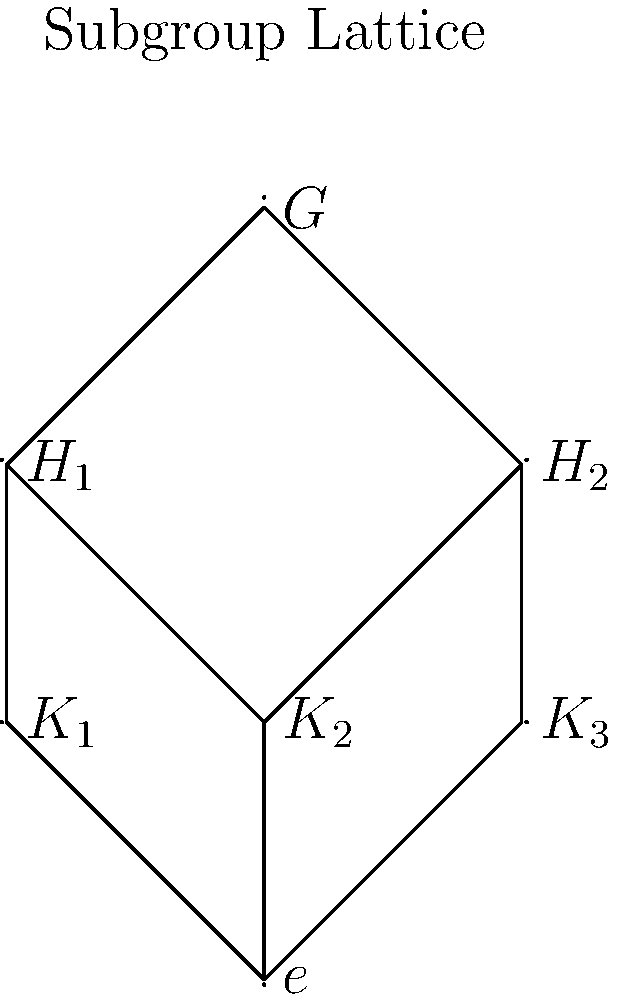Given the subgroup lattice of a finite group $G$ as shown in the diagram, how might this structure be utilized to design a hierarchical database schema for a complex system? Specifically, explain how the relationships between subgroups could be mapped to database tables and their relationships. To utilize the subgroup lattice structure in designing a hierarchical database schema, we can follow these steps:

1. Identify main entities: Each node in the lattice represents a potential entity or table in the database. In this case, we have $G$, $H_1$, $H_2$, $K_1$, $K_2$, $K_3$, and $e$.

2. Establish hierarchical relationships: The edges in the lattice represent hierarchical relationships between entities. For example, $H_1$ and $H_2$ are direct "children" of $G$.

3. Design primary and foreign keys:
   - Assign a unique identifier (primary key) to each entity.
   - Use foreign keys to represent the hierarchical relationships.

4. Create tables:
   - Create a table for each node (subgroup) in the lattice.
   - Include columns for the primary key and any relevant attributes.
   - Add foreign key columns to represent relationships with parent entities.

5. Implement constraints:
   - Use foreign key constraints to enforce the hierarchical structure.
   - Ensure that each entity can only have one direct parent (except for $G$, which is the root).

6. Handle multiple inheritance:
   - Note that $K_2$ has two parent nodes ($H_1$ and $H_2$). This represents a form of multiple inheritance.
   - Implement this using multiple foreign key relationships or a junction table.

7. Optimize for queries:
   - Consider adding redundant data or denormalization techniques to optimize for common queries that traverse the hierarchy.

8. Implement security and access control:
   - Use the hierarchical structure to implement role-based access control, where access to lower-level entities implies access to higher-level entities.

By mapping the subgroup lattice to a database schema in this way, we create a structure that reflects the mathematical properties of the group while providing an efficient and logical organization for data storage and retrieval.
Answer: Hierarchical database schema with tables representing subgroups, using primary and foreign keys to model lattice relationships, optimized for hierarchical queries and access control. 